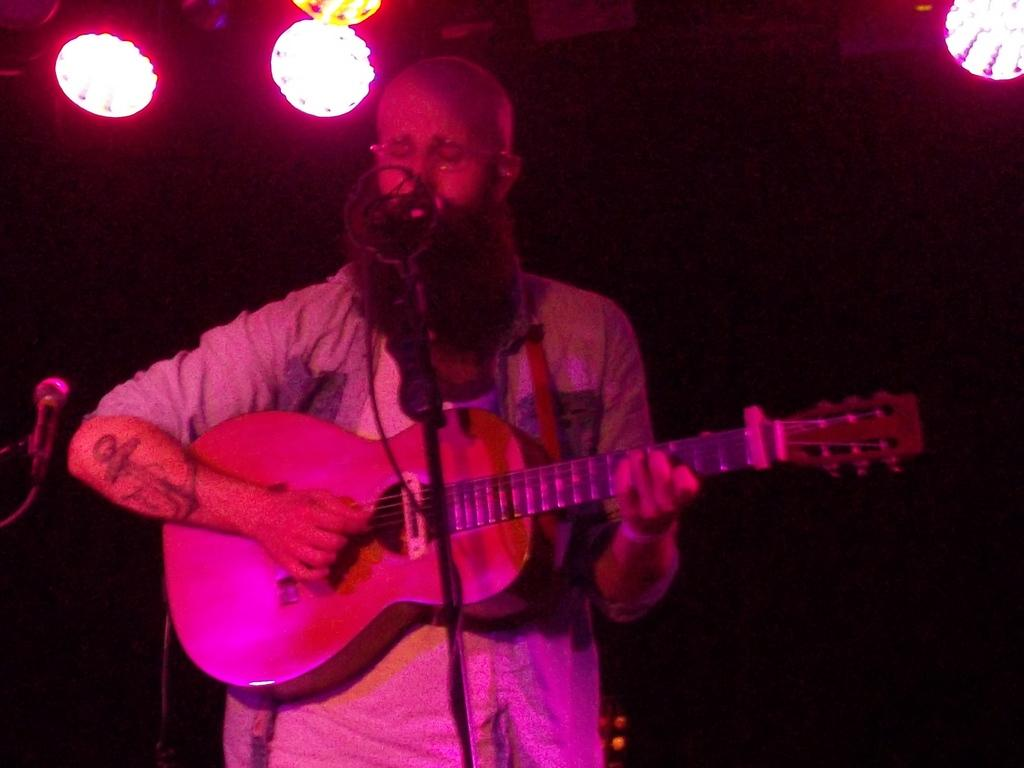What is the person in the image doing? The person is playing a guitar. What object is in front of the person? There is a microphone in front of the person. What can be seen around the person? There are lights present around the person. What type of judge is present in the image? There is no judge present in the image; it features a person playing a guitar. 